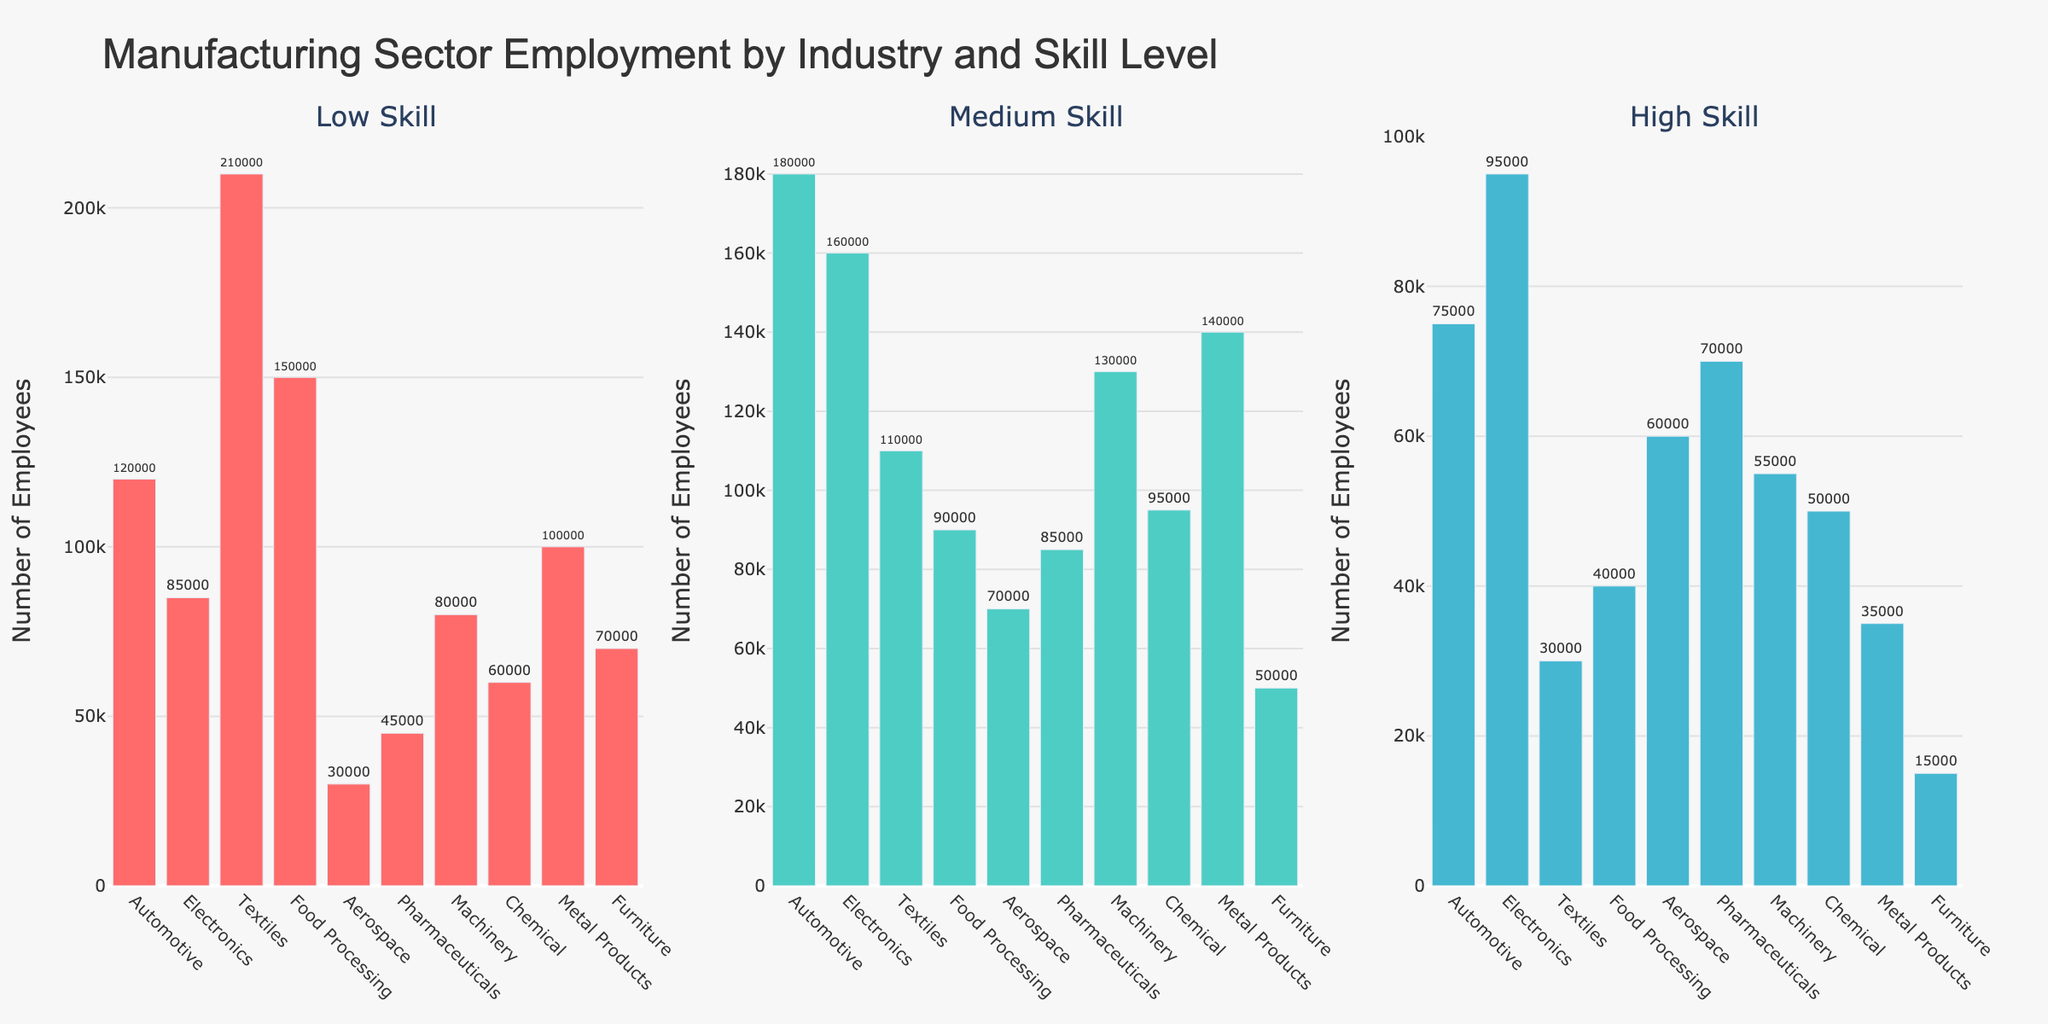What is the title of the figure? The title is usually displayed at the top of the figure. In this case, the title is "Manufacturing Sector Employment by Industry and Skill Level" as it summarizes the purpose of the visualization.
Answer: Manufacturing Sector Employment by Industry and Skill Level How does the number of employees in the automotive industry for low skill compare to those in the aerospace industry for low skill? Looking at the histogram for "Low Skill" workers, identify the bars for Automotive and Aerospace industries. The Automotive industry has 120,000 low-skill employees, while the Aerospace industry has 30,000.
Answer: Automotive has 90,000 more Which industry employs the most medium-skilled workers? By examining the "Medium Skill" histogram, compare the heights of the bars. The Automotive industry has the tallest bar, representing the highest number of medium-skilled employees (180,000).
Answer: Automotive What is the total number of high-skill employees in the textiles and pharmaceuticals industries combined? Look at the "High Skill" histogram. For Textiles, the number is 30,000. For Pharmaceuticals, it is 70,000. Adding these two numbers yields 100,000.
Answer: 100,000 Is the number of high-skill employees in the machinery industry greater than those in the chemical industry? In the "High Skill" histogram, the Machinery industry has 55,000 high-skill employees, while the Chemical industry has 50,000. Comparing these two numbers, Machinery has more.
Answer: Yes Which industry has the lowest number of medium-skill employees? Examine the "Medium Skill" histogram to find the shortest bar. The Food Processing industry has the lowest number of medium-skill employees at 90,000.
Answer: Food Processing How many more low-skill employees does the textiles industry have compared to medium-skill employees? From the "Low Skill" histogram, the Textiles industry has 210,000 employees. From the "Medium Skill" histogram, it has 110,000 employees. Subtracting these, 210,000 - 110,000 = 100,000.
Answer: 100,000 What is the difference in employment between high-skill and low-skill workers in the electronics industry? Check the histograms for both "High Skill" and "Low Skill" for Electronics. Low skill has 85,000 employees and high skill has 95,000. Subtracting these, 95,000 - 85,000 = 10,000.
Answer: 10,000 Which skill level has the most variability in the number of employees across industries? Variability can be observed by comparing the range of the heights of bars within each subplot. The "Low Skill" histogram has the most variability, observable by the wide range in bar heights (from 30,000 to 210,000).
Answer: Low Skill 